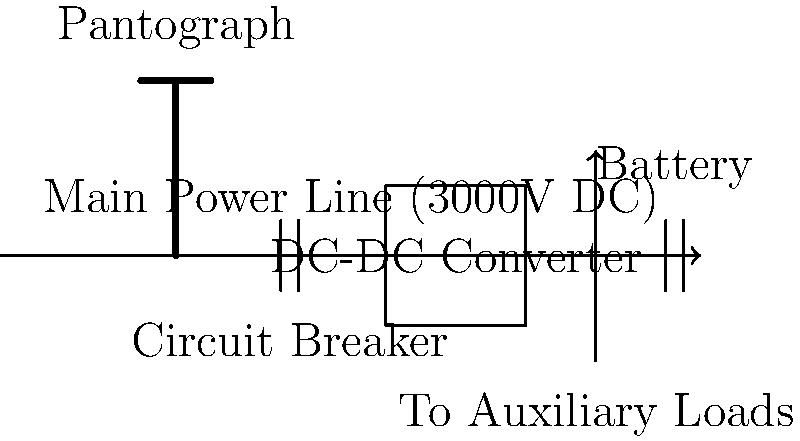In the schematic diagram of a train's electrical power distribution system shown above, what is the primary purpose of the DC-DC converter, and how does it contribute to the overall system efficiency? To answer this question, let's analyze the components and their roles in the train's electrical power distribution system:

1. Main Power Line: The system is powered by a 3000V DC main power line, which is a standard voltage for many electric train systems.

2. Pantograph: This device collects power from the overhead catenary wire, bringing the 3000V DC into the train's electrical system.

3. Circuit Breaker: This component provides protection against overcurrent and short circuits.

4. DC-DC Converter: This is the focus of our question. Its primary purposes are:

   a) Voltage Conversion: The DC-DC converter steps down the high voltage (3000V DC) from the main power line to lower voltages suitable for various train systems and equipment.
   
   b) Voltage Regulation: It maintains a stable output voltage despite fluctuations in the input voltage or load demands.

5. Auxiliary Loads: These represent various electrical systems in the train that require power at different voltage levels.

6. Battery: This provides backup power and helps stabilize the electrical system.

The DC-DC converter contributes to overall system efficiency in several ways:

1. Optimal Voltage Levels: By providing the correct voltage levels for different subsystems, it ensures that each component operates at its designed efficiency.

2. Reduced Power Loss: Converting high voltage to lower voltages where it's needed reduces power loss in distribution.

3. Power Quality: By regulating voltage, it protects sensitive equipment from voltage fluctuations, potentially extending their lifespan and reducing maintenance needs.

4. Energy Recovery: In advanced systems, DC-DC converters can be bidirectional, allowing for regenerative braking energy to be fed back into the main power line or battery storage.

5. Weight Reduction: Efficient power conversion allows for smaller, lighter electrical components throughout the train, indirectly improving the train's energy efficiency.
Answer: The DC-DC converter steps down and regulates voltage for efficient power distribution and equipment operation. 